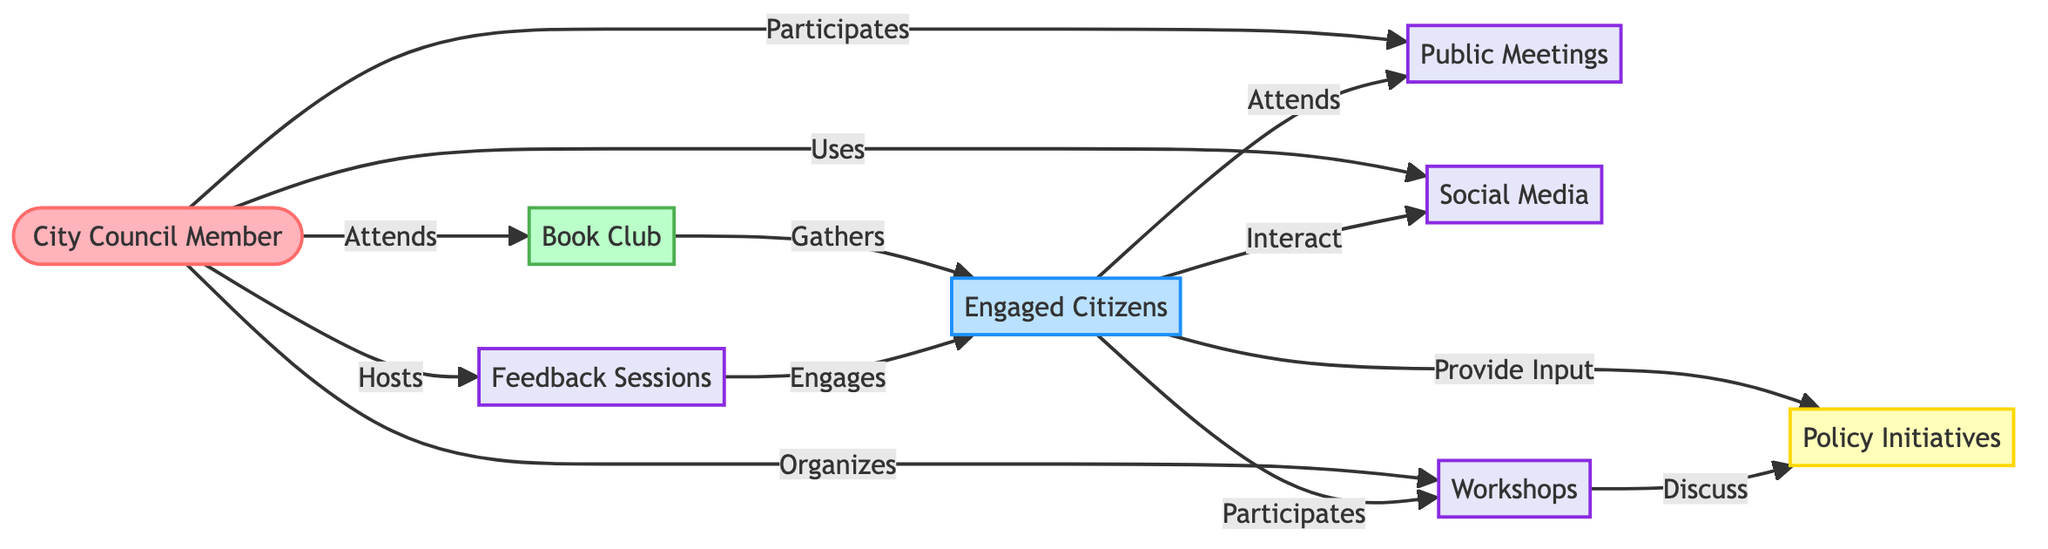What is the total number of nodes in the diagram? The diagram lists eight nodes: City Council Member, Book Club, Engaged Citizens, Policy Initiatives, Feedback Sessions, Public Meetings, Social Media, and Workshops. Counting these gives a total of eight nodes.
Answer: eight How many distinct types of interactions are present in the diagram? The diagram highlights four distinct types of interactions: Feedback Sessions, Public Meetings, Social Media, and Workshops. This can be verified by reviewing the interaction nodes.
Answer: four What action does the City Council Member take towards the Book Club? The Council Member is connected to the Book Club with an edge labeled "Attends." This link indicates that the Council Member participates in the activities of the Book Club.
Answer: Attends Which group provides input to Policy Initiatives? The edge labeled "Provide Input" indicates a direct connection from Engaged Citizens to Policy Initiatives, showing that citizens play a role in influencing policy decisions.
Answer: Engaged Citizens What is the relationship between Workshops and Policy Initiatives? The Workshops node is connected to the Policy Initiatives node with an edge labeled "Discuss." This indicates that discussions during workshops contribute to the development of policy initiatives.
Answer: Discuss How do Citizens engage with Social Media according to the diagram? The Citizens node is linked to the Social Media node with an edge labeled "Interact," indicating that citizens actively participate and engage with social media outlets.
Answer: Interact Who hosts the Feedback Sessions? The edge labeled "Hosts" shows a direct relationship where the City Council Member is responsible for organizing the Feedback Sessions, indicating their active role in facilitating citizen engagement.
Answer: City Council Member How do Book Clubs gather Citizens? The connection from the Book Club to Citizens shows an edge labeled "Gathers," implying that the Book Club serves as a space or event where citizens come together, emphasizing community involvement.
Answer: Gathers What role do Citizens play in Public Meetings? The edge connecting Citizens to Public Meetings is labeled "Attends," indicating that citizens have a participatory role in these meetings, likely influencing local governance.
Answer: Attends 